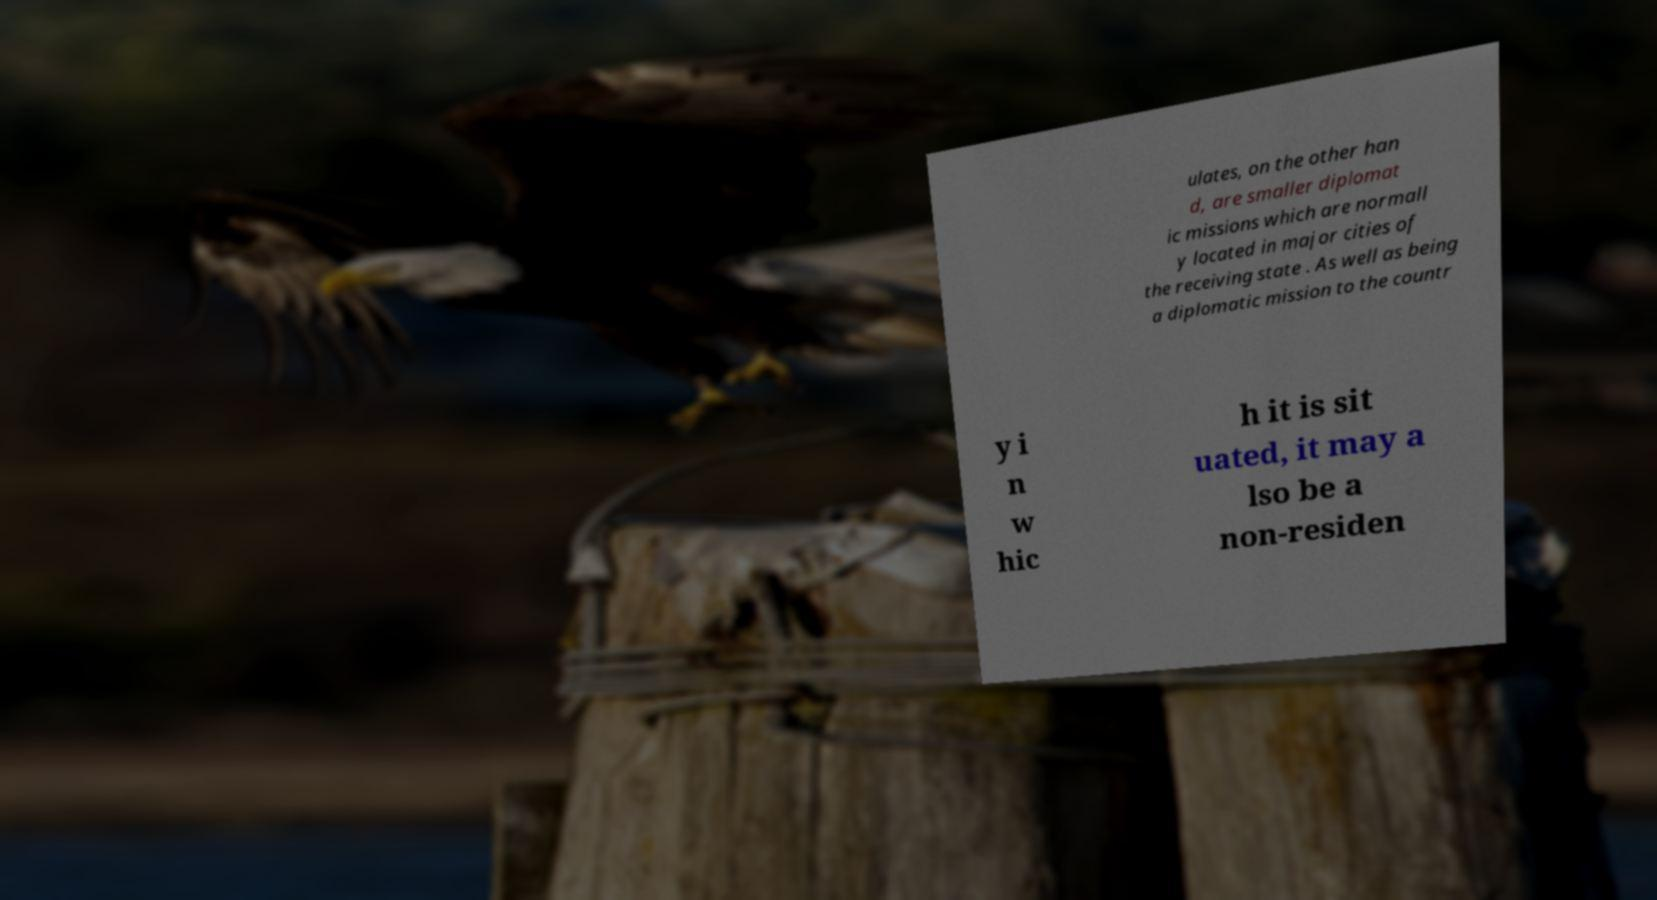There's text embedded in this image that I need extracted. Can you transcribe it verbatim? ulates, on the other han d, are smaller diplomat ic missions which are normall y located in major cities of the receiving state . As well as being a diplomatic mission to the countr y i n w hic h it is sit uated, it may a lso be a non-residen 